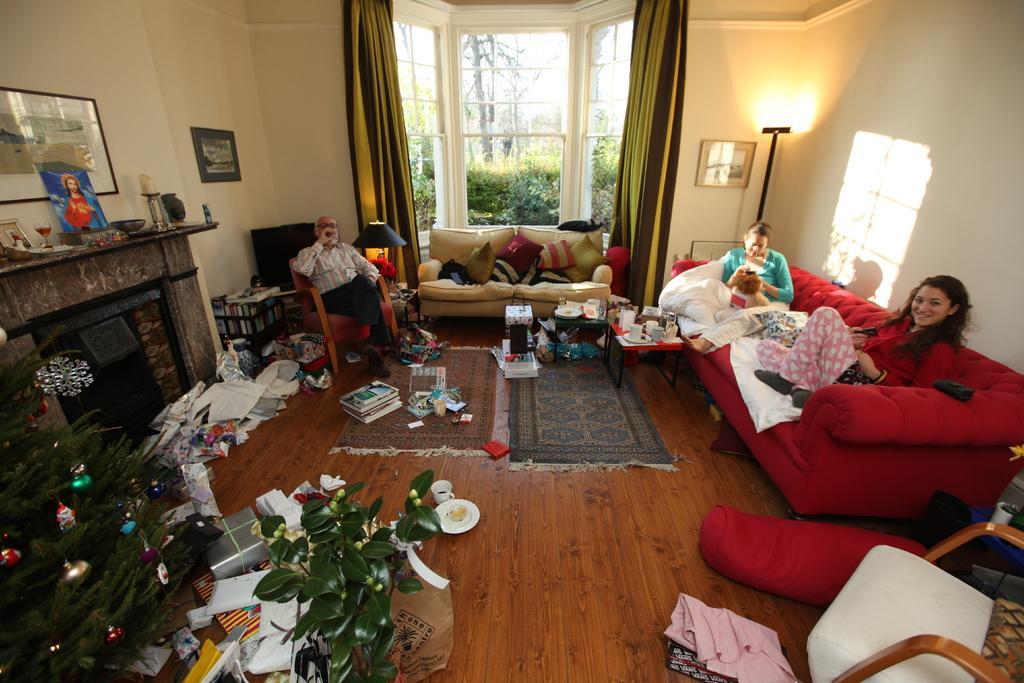In one or two sentences, can you explain what this image depicts? The picture shows an inner view of a house we see three people seated and we see a plant and a photo frame on the wall 